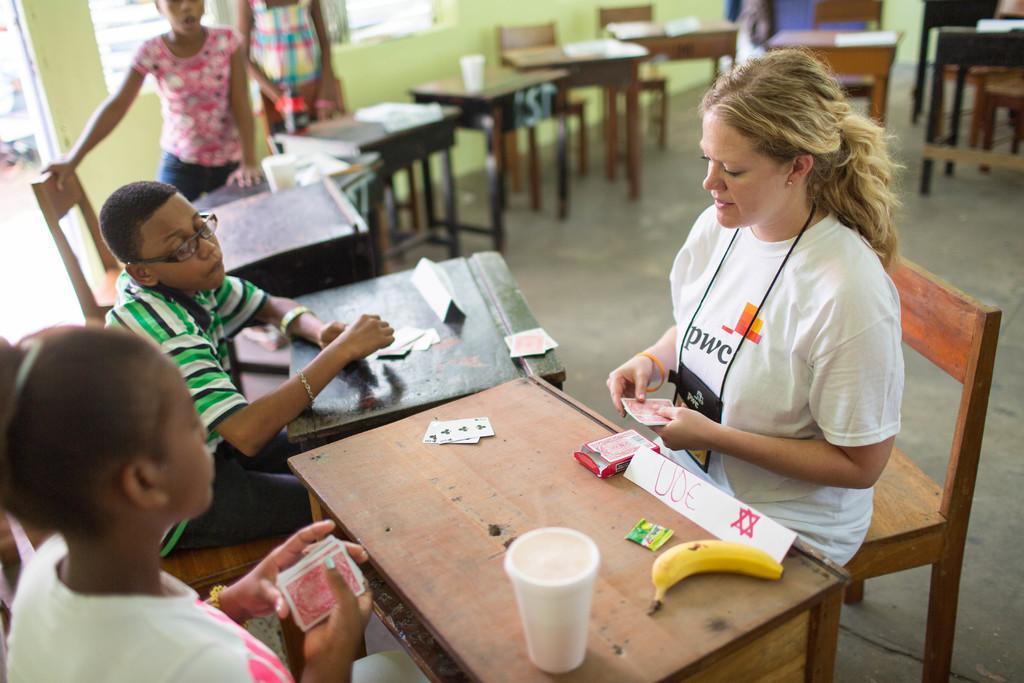Could you give a brief overview of what you see in this image? This image is clicked inside which includes many number of tables and chairs. There are some papers and glasses which is placed on the top of the table. On the right there is a Woman sitting on the chair and playing cards. In the center there is a table on which a banana and a glass is placed. On the left there is a Girl and a Boy sitting on chair and playing cards. At the top left there are two persons standing and there is a wall and a window in the background. 